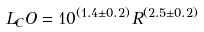<formula> <loc_0><loc_0><loc_500><loc_500>L _ { C } O = 1 0 ^ { ( 1 . 4 \pm 0 . 2 ) } R ^ { ( 2 . 5 \pm 0 . 2 ) }</formula> 